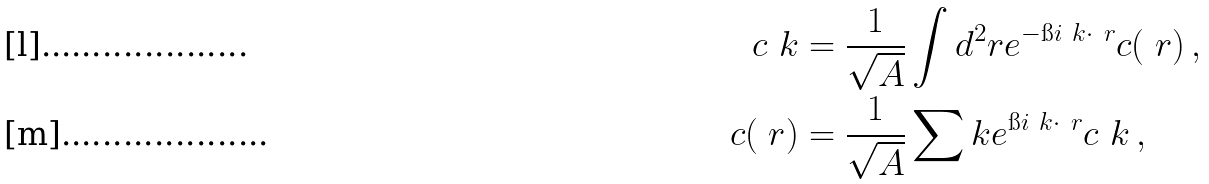Convert formula to latex. <formula><loc_0><loc_0><loc_500><loc_500>c _ { \ } k & = \frac { 1 } { \sqrt { A } } \int d ^ { 2 } r e ^ { - \i i \ k \cdot \ r } c ( \ r ) \, , \\ c ( \ r ) & = \frac { 1 } { \sqrt { A } } \sum _ { \ } k e ^ { \i i \ k \cdot \ r } c _ { \ } k \, ,</formula> 